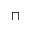<formula> <loc_0><loc_0><loc_500><loc_500>\sqcap</formula> 